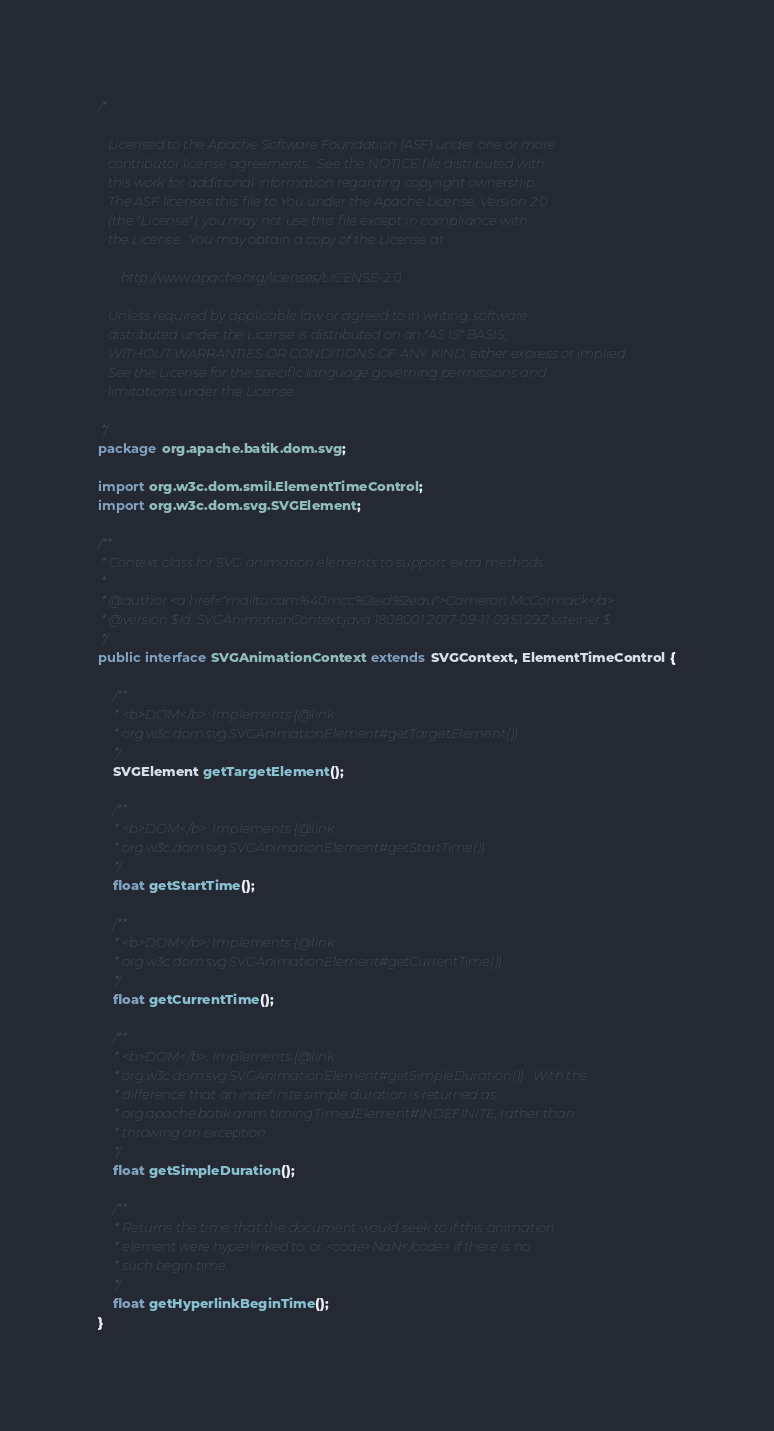Convert code to text. <code><loc_0><loc_0><loc_500><loc_500><_Java_>/*

   Licensed to the Apache Software Foundation (ASF) under one or more
   contributor license agreements.  See the NOTICE file distributed with
   this work for additional information regarding copyright ownership.
   The ASF licenses this file to You under the Apache License, Version 2.0
   (the "License"); you may not use this file except in compliance with
   the License.  You may obtain a copy of the License at

       http://www.apache.org/licenses/LICENSE-2.0

   Unless required by applicable law or agreed to in writing, software
   distributed under the License is distributed on an "AS IS" BASIS,
   WITHOUT WARRANTIES OR CONDITIONS OF ANY KIND, either express or implied.
   See the License for the specific language governing permissions and
   limitations under the License.

 */
package org.apache.batik.dom.svg;

import org.w3c.dom.smil.ElementTimeControl;
import org.w3c.dom.svg.SVGElement;

/**
 * Context class for SVG animation elements to support extra methods.
 *
 * @author <a href="mailto:cam%40mcc%2eid%2eau">Cameron McCormack</a>
 * @version $Id: SVGAnimationContext.java 1808001 2017-09-11 09:51:29Z ssteiner $
 */
public interface SVGAnimationContext extends SVGContext, ElementTimeControl {

    /**
     * <b>DOM</b>: Implements {@link
     * org.w3c.dom.svg.SVGAnimationElement#getTargetElement()}.
     */
    SVGElement getTargetElement();

    /**
     * <b>DOM</b>: Implements {@link
     * org.w3c.dom.svg.SVGAnimationElement#getStartTime()}.
     */
    float getStartTime();

    /**
     * <b>DOM</b>: Implements {@link
     * org.w3c.dom.svg.SVGAnimationElement#getCurrentTime()}.
     */
    float getCurrentTime();

    /**
     * <b>DOM</b>: Implements {@link
     * org.w3c.dom.svg.SVGAnimationElement#getSimpleDuration()}.  With the
     * difference that an indefinite simple duration is returned as
     * org.apache.batik.anim.timing.TimedElement#INDEFINITE, rather than
     * throwing an exception.
     */
    float getSimpleDuration();

    /**
     * Returns the time that the document would seek to if this animation
     * element were hyperlinked to, or <code>NaN</code> if there is no
     * such begin time.
     */
    float getHyperlinkBeginTime();
}
</code> 